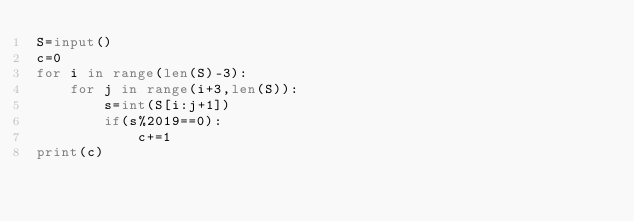<code> <loc_0><loc_0><loc_500><loc_500><_Python_>S=input()
c=0
for i in range(len(S)-3):
    for j in range(i+3,len(S)):
        s=int(S[i:j+1])
        if(s%2019==0):
            c+=1
print(c)</code> 